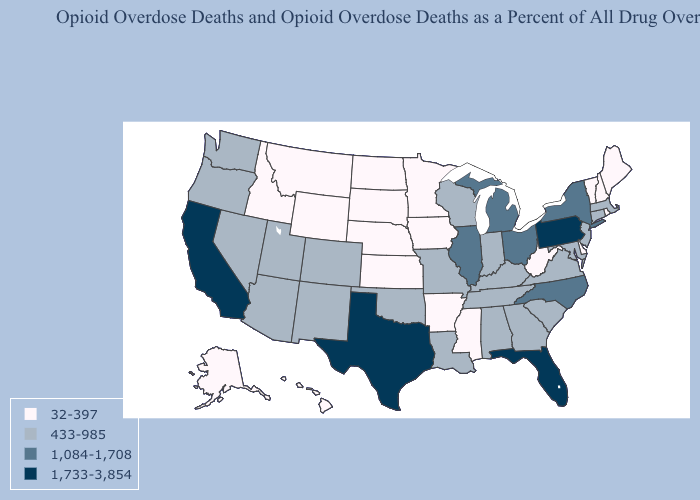What is the value of Nebraska?
Quick response, please. 32-397. Does Nebraska have a lower value than Montana?
Short answer required. No. Does South Dakota have the same value as Montana?
Give a very brief answer. Yes. How many symbols are there in the legend?
Be succinct. 4. Among the states that border Arkansas , does Mississippi have the lowest value?
Keep it brief. Yes. Which states have the lowest value in the USA?
Short answer required. Alaska, Arkansas, Delaware, Hawaii, Idaho, Iowa, Kansas, Maine, Minnesota, Mississippi, Montana, Nebraska, New Hampshire, North Dakota, Rhode Island, South Dakota, Vermont, West Virginia, Wyoming. Name the states that have a value in the range 32-397?
Answer briefly. Alaska, Arkansas, Delaware, Hawaii, Idaho, Iowa, Kansas, Maine, Minnesota, Mississippi, Montana, Nebraska, New Hampshire, North Dakota, Rhode Island, South Dakota, Vermont, West Virginia, Wyoming. Among the states that border Tennessee , which have the highest value?
Keep it brief. North Carolina. Which states have the lowest value in the USA?
Be succinct. Alaska, Arkansas, Delaware, Hawaii, Idaho, Iowa, Kansas, Maine, Minnesota, Mississippi, Montana, Nebraska, New Hampshire, North Dakota, Rhode Island, South Dakota, Vermont, West Virginia, Wyoming. Does North Dakota have the highest value in the MidWest?
Give a very brief answer. No. What is the value of Virginia?
Short answer required. 433-985. Name the states that have a value in the range 433-985?
Answer briefly. Alabama, Arizona, Colorado, Connecticut, Georgia, Indiana, Kentucky, Louisiana, Maryland, Massachusetts, Missouri, Nevada, New Jersey, New Mexico, Oklahoma, Oregon, South Carolina, Tennessee, Utah, Virginia, Washington, Wisconsin. Among the states that border Montana , which have the highest value?
Keep it brief. Idaho, North Dakota, South Dakota, Wyoming. Is the legend a continuous bar?
Be succinct. No. Does the first symbol in the legend represent the smallest category?
Keep it brief. Yes. 